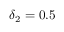Convert formula to latex. <formula><loc_0><loc_0><loc_500><loc_500>\delta _ { 2 } = 0 . 5</formula> 